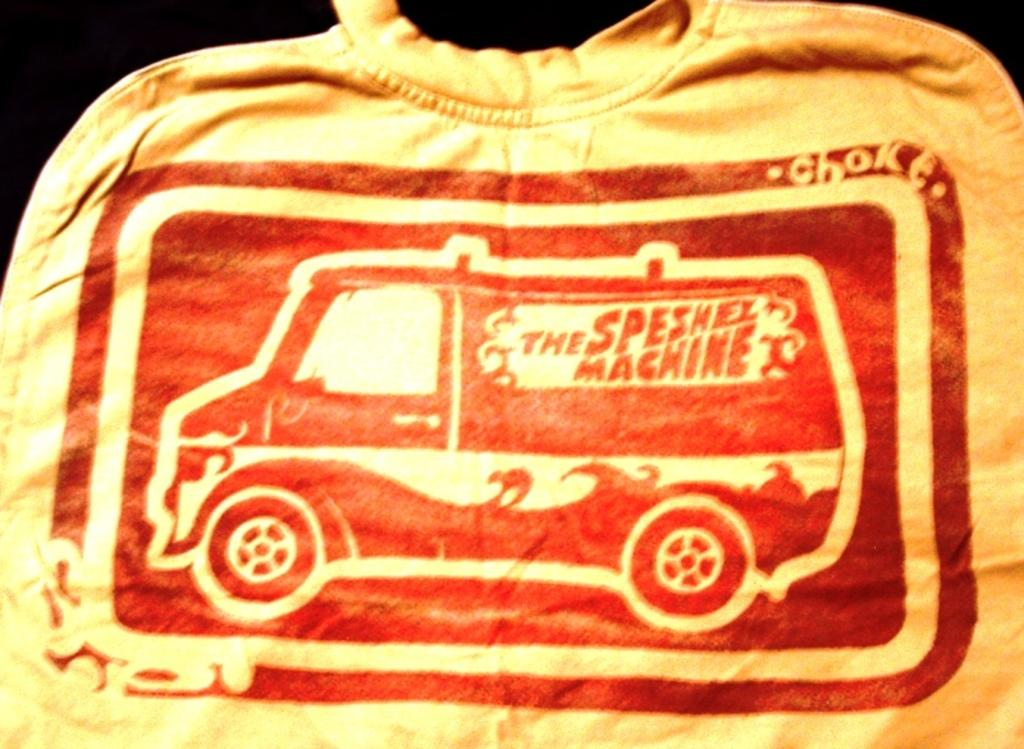What type of clothing item is in the image? There is a t-shirt in the image. What is depicted on the t-shirt? The t-shirt has a picture of a truck. Are there any words or phrases on the t-shirt? Yes, there is text on the t-shirt. What type of flame can be seen on the t-shirt? There is no flame present on the t-shirt; it has a picture of a truck and text. Is there any indication of a fight happening in the image? No, there is no indication of a fight in the image; it only shows a t-shirt with a truck picture and text. 